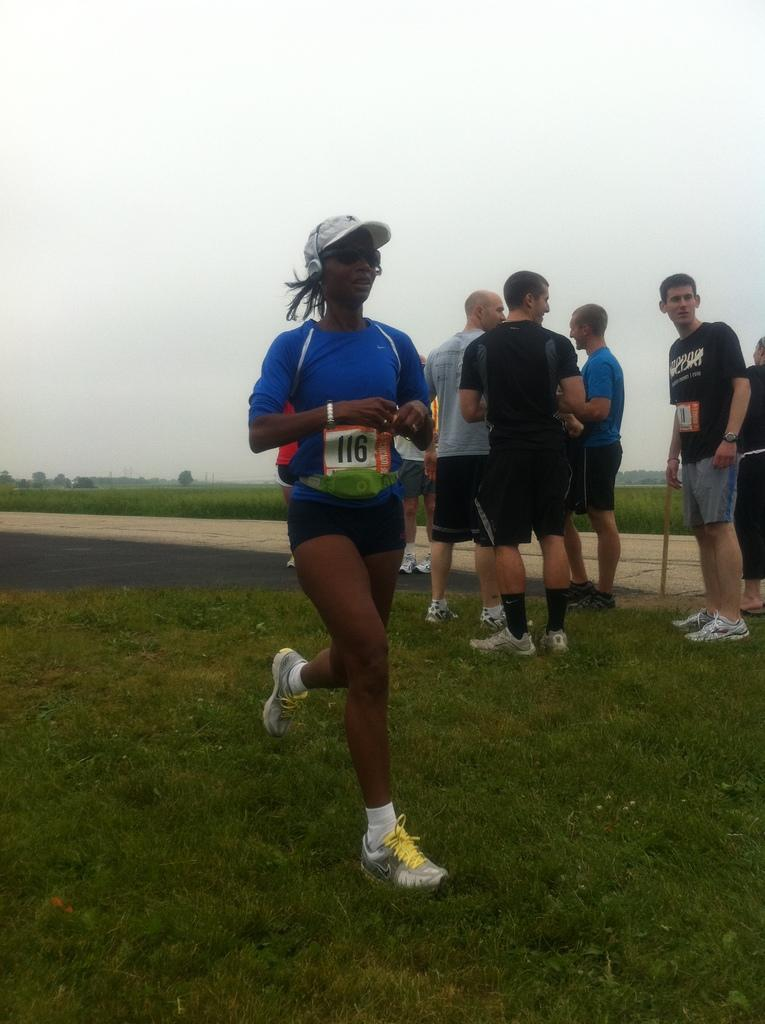What type of vegetation is present in the image? There is grass in the image. Can you describe the people in the image? There are people standing in the image. What is the surface that the grass and people are on? The ground is visible in the image. What other natural elements can be seen in the image? There are trees in the image. What is visible in the background of the image? The sky is visible in the background of the image. What type of egg is being used as a prop by the farmer in the image? There is no farmer or egg present in the image. What idea is being discussed by the people in the image? The image does not provide any information about a discussion or idea among the people. 